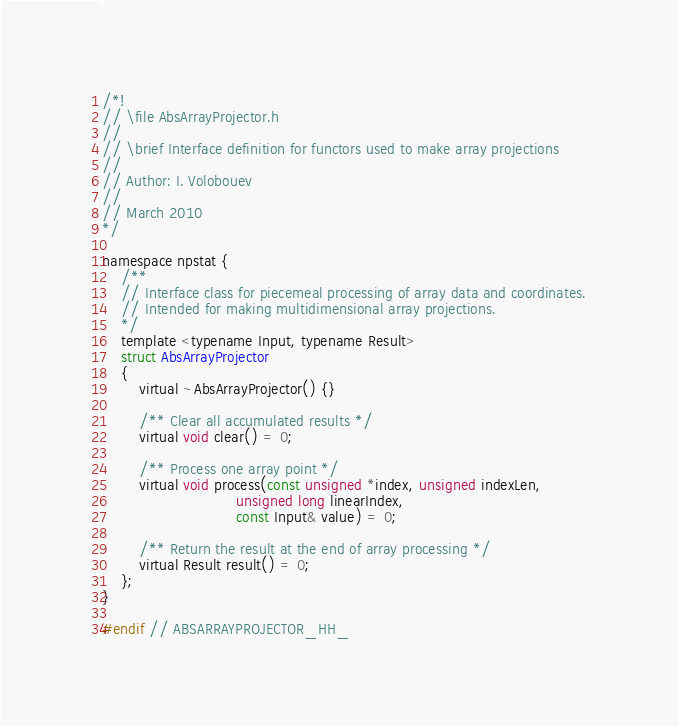Convert code to text. <code><loc_0><loc_0><loc_500><loc_500><_C_>/*!
// \file AbsArrayProjector.h
//
// \brief Interface definition for functors used to make array projections
//
// Author: I. Volobouev
//
// March 2010
*/

namespace npstat {
    /**
    // Interface class for piecemeal processing of array data and coordinates.
    // Intended for making multidimensional array projections.
    */
    template <typename Input, typename Result>
    struct AbsArrayProjector
    {
        virtual ~AbsArrayProjector() {}

        /** Clear all accumulated results */
        virtual void clear() = 0;

        /** Process one array point */
        virtual void process(const unsigned *index, unsigned indexLen,
                             unsigned long linearIndex,
                             const Input& value) = 0;

        /** Return the result at the end of array processing */
        virtual Result result() = 0;
    };
}

#endif // ABSARRAYPROJECTOR_HH_

</code> 